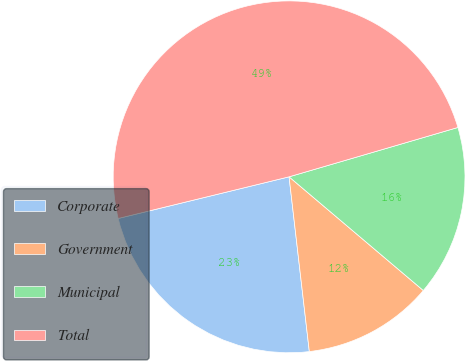Convert chart. <chart><loc_0><loc_0><loc_500><loc_500><pie_chart><fcel>Corporate<fcel>Government<fcel>Municipal<fcel>Total<nl><fcel>23.03%<fcel>11.98%<fcel>15.71%<fcel>49.28%<nl></chart> 